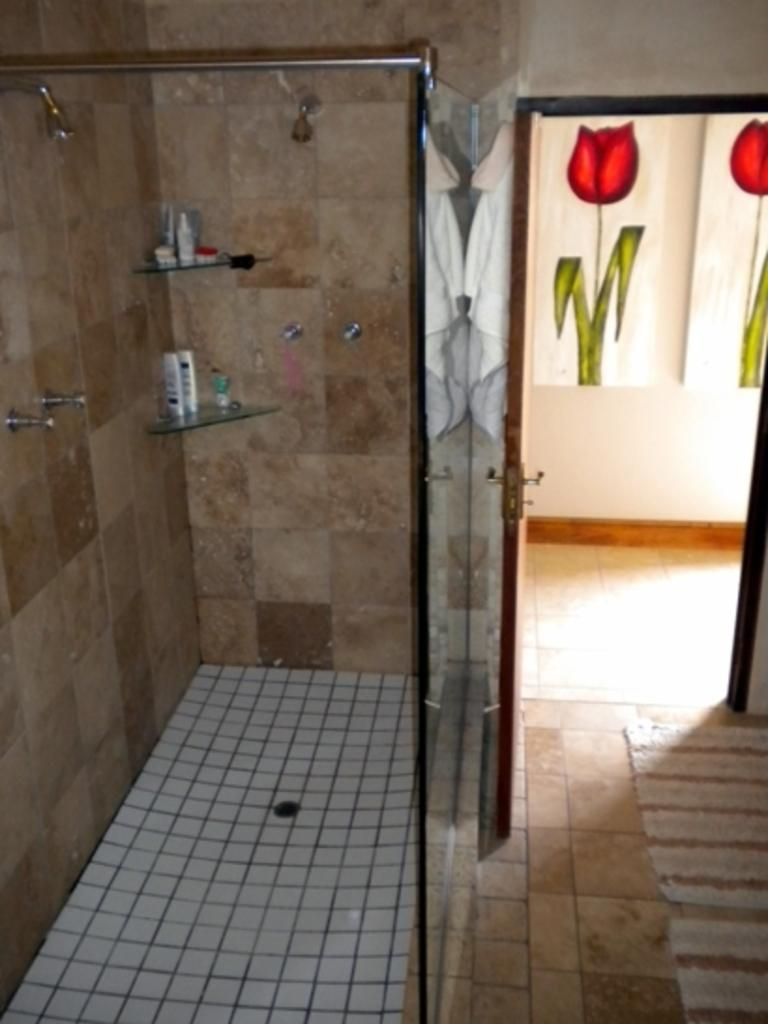What type of room is shown in the image? The image depicts a restroom. Where is the door located in the image? The door is on the right side of the image. What items can be seen on the left side of the image? There are toiletries on the left side of the image. What is visible in the background of the image? There is a wall visible in the background of the image. How does the father contribute to the cleanliness of the restroom in the image? There is no father present in the image, and therefore no such contribution can be observed. 